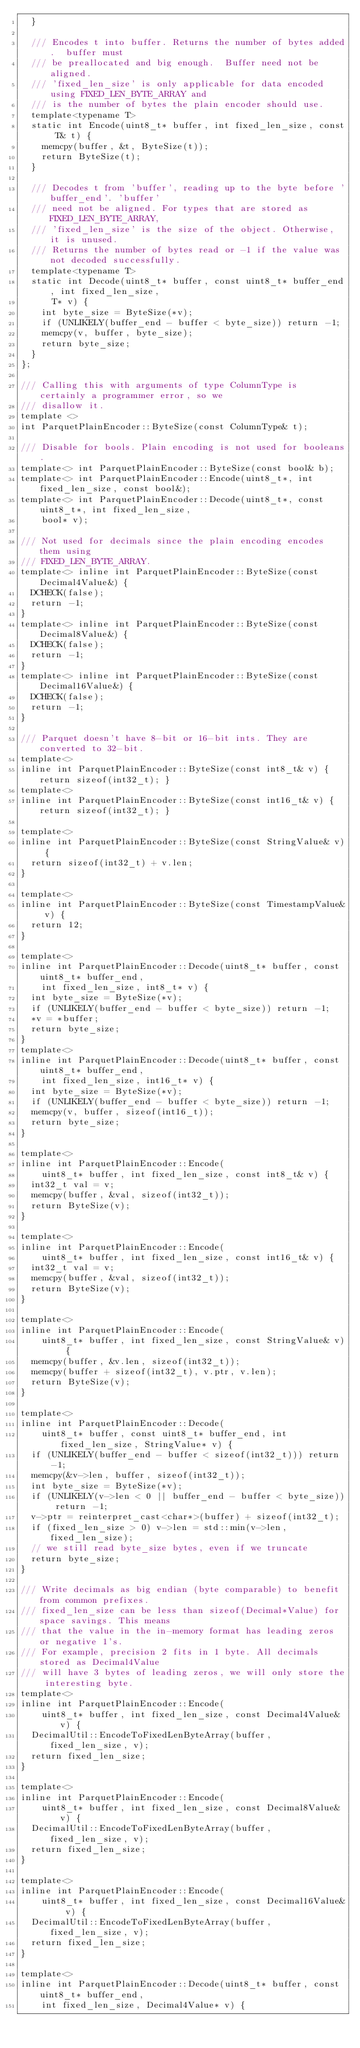Convert code to text. <code><loc_0><loc_0><loc_500><loc_500><_C_>  }

  /// Encodes t into buffer. Returns the number of bytes added.  buffer must
  /// be preallocated and big enough.  Buffer need not be aligned.
  /// 'fixed_len_size' is only applicable for data encoded using FIXED_LEN_BYTE_ARRAY and
  /// is the number of bytes the plain encoder should use.
  template<typename T>
  static int Encode(uint8_t* buffer, int fixed_len_size, const T& t) {
    memcpy(buffer, &t, ByteSize(t));
    return ByteSize(t);
  }

  /// Decodes t from 'buffer', reading up to the byte before 'buffer_end'. 'buffer'
  /// need not be aligned. For types that are stored as FIXED_LEN_BYTE_ARRAY,
  /// 'fixed_len_size' is the size of the object. Otherwise, it is unused.
  /// Returns the number of bytes read or -1 if the value was not decoded successfully.
  template<typename T>
  static int Decode(uint8_t* buffer, const uint8_t* buffer_end, int fixed_len_size,
      T* v) {
    int byte_size = ByteSize(*v);
    if (UNLIKELY(buffer_end - buffer < byte_size)) return -1;
    memcpy(v, buffer, byte_size);
    return byte_size;
  }
};

/// Calling this with arguments of type ColumnType is certainly a programmer error, so we
/// disallow it.
template <>
int ParquetPlainEncoder::ByteSize(const ColumnType& t);

/// Disable for bools. Plain encoding is not used for booleans.
template<> int ParquetPlainEncoder::ByteSize(const bool& b);
template<> int ParquetPlainEncoder::Encode(uint8_t*, int fixed_len_size, const bool&);
template<> int ParquetPlainEncoder::Decode(uint8_t*, const uint8_t*, int fixed_len_size,
    bool* v);

/// Not used for decimals since the plain encoding encodes them using
/// FIXED_LEN_BYTE_ARRAY.
template<> inline int ParquetPlainEncoder::ByteSize(const Decimal4Value&) {
  DCHECK(false);
  return -1;
}
template<> inline int ParquetPlainEncoder::ByteSize(const Decimal8Value&) {
  DCHECK(false);
  return -1;
}
template<> inline int ParquetPlainEncoder::ByteSize(const Decimal16Value&) {
  DCHECK(false);
  return -1;
}

/// Parquet doesn't have 8-bit or 16-bit ints. They are converted to 32-bit.
template<>
inline int ParquetPlainEncoder::ByteSize(const int8_t& v) { return sizeof(int32_t); }
template<>
inline int ParquetPlainEncoder::ByteSize(const int16_t& v) { return sizeof(int32_t); }

template<>
inline int ParquetPlainEncoder::ByteSize(const StringValue& v) {
  return sizeof(int32_t) + v.len;
}

template<>
inline int ParquetPlainEncoder::ByteSize(const TimestampValue& v) {
  return 12;
}

template<>
inline int ParquetPlainEncoder::Decode(uint8_t* buffer, const uint8_t* buffer_end,
    int fixed_len_size, int8_t* v) {
  int byte_size = ByteSize(*v);
  if (UNLIKELY(buffer_end - buffer < byte_size)) return -1;
  *v = *buffer;
  return byte_size;
}
template<>
inline int ParquetPlainEncoder::Decode(uint8_t* buffer, const uint8_t* buffer_end,
    int fixed_len_size, int16_t* v) {
  int byte_size = ByteSize(*v);
  if (UNLIKELY(buffer_end - buffer < byte_size)) return -1;
  memcpy(v, buffer, sizeof(int16_t));
  return byte_size;
}

template<>
inline int ParquetPlainEncoder::Encode(
    uint8_t* buffer, int fixed_len_size, const int8_t& v) {
  int32_t val = v;
  memcpy(buffer, &val, sizeof(int32_t));
  return ByteSize(v);
}

template<>
inline int ParquetPlainEncoder::Encode(
    uint8_t* buffer, int fixed_len_size, const int16_t& v) {
  int32_t val = v;
  memcpy(buffer, &val, sizeof(int32_t));
  return ByteSize(v);
}

template<>
inline int ParquetPlainEncoder::Encode(
    uint8_t* buffer, int fixed_len_size, const StringValue& v) {
  memcpy(buffer, &v.len, sizeof(int32_t));
  memcpy(buffer + sizeof(int32_t), v.ptr, v.len);
  return ByteSize(v);
}

template<>
inline int ParquetPlainEncoder::Decode(
    uint8_t* buffer, const uint8_t* buffer_end, int fixed_len_size, StringValue* v) {
  if (UNLIKELY(buffer_end - buffer < sizeof(int32_t))) return -1;
  memcpy(&v->len, buffer, sizeof(int32_t));
  int byte_size = ByteSize(*v);
  if (UNLIKELY(v->len < 0 || buffer_end - buffer < byte_size)) return -1;
  v->ptr = reinterpret_cast<char*>(buffer) + sizeof(int32_t);
  if (fixed_len_size > 0) v->len = std::min(v->len, fixed_len_size);
  // we still read byte_size bytes, even if we truncate
  return byte_size;
}

/// Write decimals as big endian (byte comparable) to benefit from common prefixes.
/// fixed_len_size can be less than sizeof(Decimal*Value) for space savings. This means
/// that the value in the in-memory format has leading zeros or negative 1's.
/// For example, precision 2 fits in 1 byte. All decimals stored as Decimal4Value
/// will have 3 bytes of leading zeros, we will only store the interesting byte.
template<>
inline int ParquetPlainEncoder::Encode(
    uint8_t* buffer, int fixed_len_size, const Decimal4Value& v) {
  DecimalUtil::EncodeToFixedLenByteArray(buffer, fixed_len_size, v);
  return fixed_len_size;
}

template<>
inline int ParquetPlainEncoder::Encode(
    uint8_t* buffer, int fixed_len_size, const Decimal8Value& v) {
  DecimalUtil::EncodeToFixedLenByteArray(buffer, fixed_len_size, v);
  return fixed_len_size;
}

template<>
inline int ParquetPlainEncoder::Encode(
    uint8_t* buffer, int fixed_len_size, const Decimal16Value& v) {
  DecimalUtil::EncodeToFixedLenByteArray(buffer, fixed_len_size, v);
  return fixed_len_size;
}

template<>
inline int ParquetPlainEncoder::Decode(uint8_t* buffer, const uint8_t* buffer_end,
    int fixed_len_size, Decimal4Value* v) {</code> 